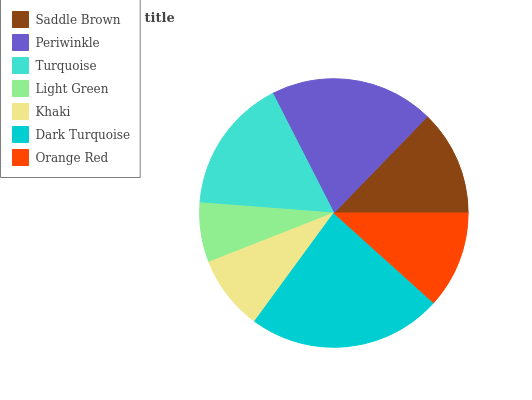Is Light Green the minimum?
Answer yes or no. Yes. Is Dark Turquoise the maximum?
Answer yes or no. Yes. Is Periwinkle the minimum?
Answer yes or no. No. Is Periwinkle the maximum?
Answer yes or no. No. Is Periwinkle greater than Saddle Brown?
Answer yes or no. Yes. Is Saddle Brown less than Periwinkle?
Answer yes or no. Yes. Is Saddle Brown greater than Periwinkle?
Answer yes or no. No. Is Periwinkle less than Saddle Brown?
Answer yes or no. No. Is Saddle Brown the high median?
Answer yes or no. Yes. Is Saddle Brown the low median?
Answer yes or no. Yes. Is Dark Turquoise the high median?
Answer yes or no. No. Is Dark Turquoise the low median?
Answer yes or no. No. 